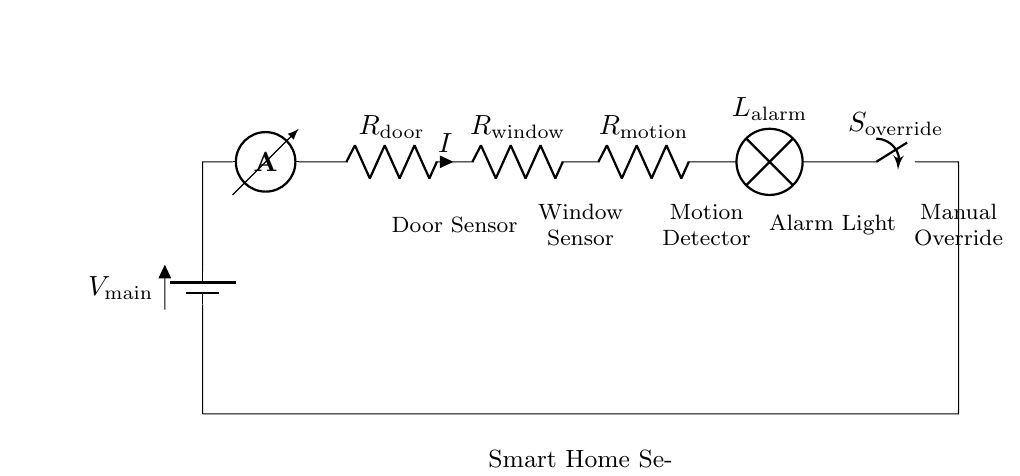What is the main voltage source in this circuit? The main voltage source is labeled as V main, which supplies electrical energy to the entire circuit.
Answer: V main How many resistors are present in the circuit? The circuit diagram shows three resistors: R door, R window, and R motion. They are connected in series.
Answer: Three What component indicates an alarm in the system? The lamp labeled L alarm represents the alarm in the security system, which activates when the circuit is completed.
Answer: L alarm Which component allows for manual control of the system? The switch labeled S override allows the user to manually override the system and control its operation.
Answer: S override What happens if one of the sensors is triggered in a series circuit? In a series circuit, if one sensor (or resistor) fails or is triggered, the entire circuit will interrupt current flow, causing all components to stop working.
Answer: Interrupts circuit What is the function of the ammeter in this circuit? The ammeter measures the current flowing through the circuit, providing insights into the system's operational status.
Answer: Measures current What is the nature of the circuit configuration? The circuit is a series circuit, where components are connected in a single path so the current flow is the same through all components.
Answer: Series circuit 